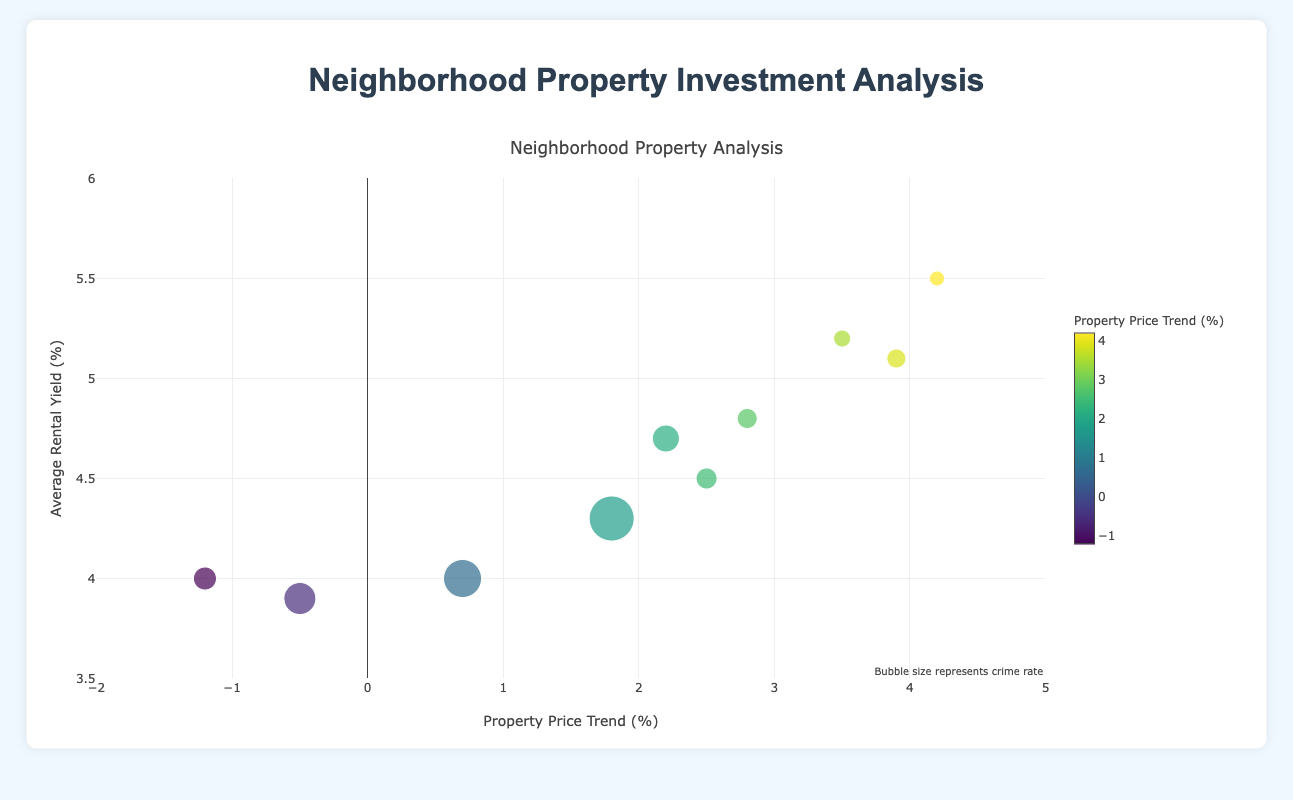What does the color of the bubbles represent? The color of the bubbles represents the property price trend percentage. The exact values can be seen in the color bar next to the chart.
Answer: Property price trend percentage What neighborhood has the bubble with the largest size and what does that indicate? The largest bubble is for Downtown, indicating it has the highest crime rate among the neighborhoods. The bubble size represents the crime rate multiplied by ten.
Answer: Downtown, highest crime rate Which neighborhood has the highest property price trend percentage? By observing the colors and the x-axis values, Sunnyvale has the highest property price trend percentage of 4.2%.
Answer: Sunnyvale Which neighborhood has the lowest average rental yield? Observing the y-axis, Riverside has the lowest average rental yield of 3.9%.
Answer: Riverside Which neighborhoods have a negative property price trend? From the x-axis, Birchwood (-1.2%) and Riverside (-0.5%) have negative property price trends.
Answer: Birchwood and Riverside Which neighborhood has the highest combination of average rental yield and property price trend? Summing up the values, Sunnyvale has the highest combination with 4.2% property price trend and 5.5% average rental yield (4.2 + 5.5 = 9.7).
Answer: Sunnyvale Is there a neighborhood with both high rental yield and low crime rate? Sunnyvale has a high average rental yield of 5.5% and a low crime rate of 1.5.
Answer: Sunnyvale Which neighborhood would be considered the safest based on crime rate? The smallest bubbles indicate the safest neighborhoods; Sunnyvale has the smallest bubble with a crime rate of 1.5.
Answer: Sunnyvale What is the crime rate for Hillcrest? By looking at the size of the bubble for Hillcrest and dividing it by 10, the crime rate is 2.7.
Answer: 2.7 Which neighborhood has a property price trend closest to 0? By looking at the x-axis values, Westfield has the property price trend closest to 0, which is 0.7%.
Answer: Westfield 